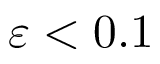<formula> <loc_0><loc_0><loc_500><loc_500>\varepsilon < 0 . 1</formula> 